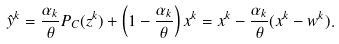Convert formula to latex. <formula><loc_0><loc_0><loc_500><loc_500>\hat { y } ^ { k } = \frac { \alpha _ { k } } { \theta } P _ { C } ( z ^ { k } ) + \left ( 1 - \frac { \alpha _ { k } } { \theta } \right ) x ^ { k } = x ^ { k } - \frac { \alpha _ { k } } { \theta } ( x ^ { k } - w ^ { k } ) .</formula> 